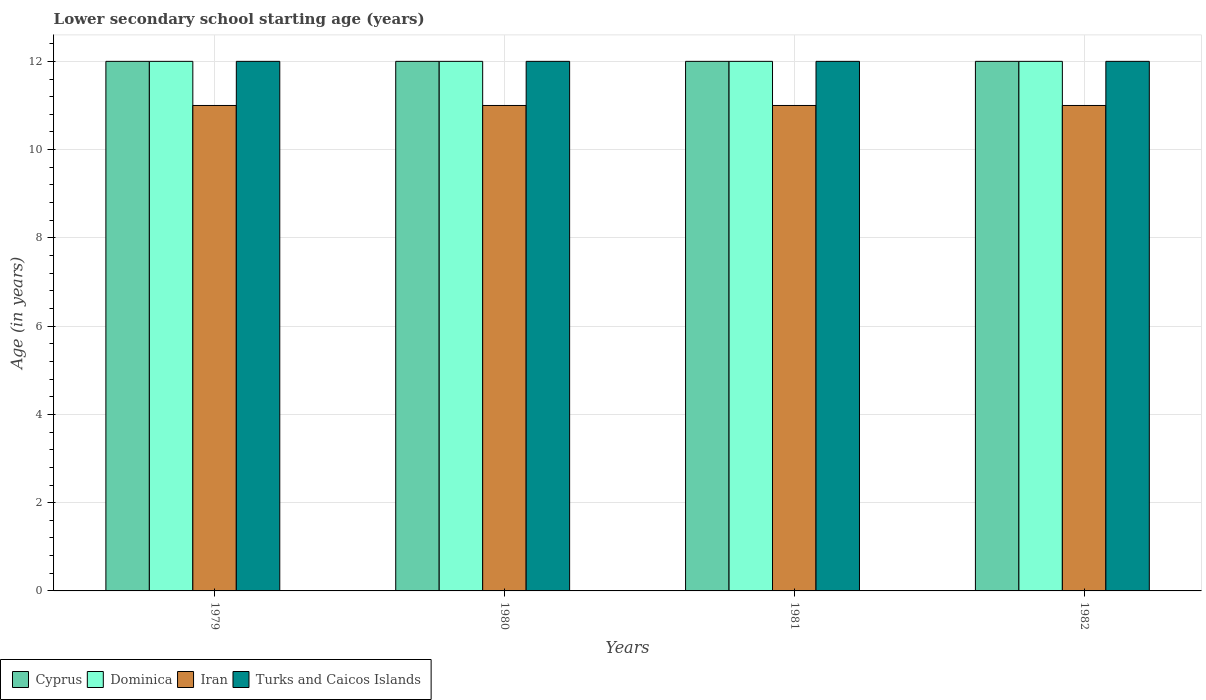How many bars are there on the 4th tick from the left?
Your answer should be very brief. 4. What is the label of the 1st group of bars from the left?
Provide a succinct answer. 1979. What is the lower secondary school starting age of children in Cyprus in 1982?
Offer a terse response. 12. Across all years, what is the minimum lower secondary school starting age of children in Iran?
Make the answer very short. 11. In which year was the lower secondary school starting age of children in Cyprus maximum?
Give a very brief answer. 1979. In which year was the lower secondary school starting age of children in Turks and Caicos Islands minimum?
Your response must be concise. 1979. What is the total lower secondary school starting age of children in Iran in the graph?
Your answer should be very brief. 44. What is the difference between the lower secondary school starting age of children in Cyprus in 1980 and that in 1981?
Provide a succinct answer. 0. In the year 1982, what is the difference between the lower secondary school starting age of children in Dominica and lower secondary school starting age of children in Cyprus?
Your answer should be compact. 0. What is the ratio of the lower secondary school starting age of children in Dominica in 1979 to that in 1982?
Provide a short and direct response. 1. What is the difference between the highest and the second highest lower secondary school starting age of children in Dominica?
Your answer should be very brief. 0. In how many years, is the lower secondary school starting age of children in Cyprus greater than the average lower secondary school starting age of children in Cyprus taken over all years?
Offer a very short reply. 0. Is it the case that in every year, the sum of the lower secondary school starting age of children in Dominica and lower secondary school starting age of children in Cyprus is greater than the sum of lower secondary school starting age of children in Turks and Caicos Islands and lower secondary school starting age of children in Iran?
Ensure brevity in your answer.  No. What does the 1st bar from the left in 1981 represents?
Your response must be concise. Cyprus. What does the 3rd bar from the right in 1981 represents?
Give a very brief answer. Dominica. Are all the bars in the graph horizontal?
Provide a succinct answer. No. What is the difference between two consecutive major ticks on the Y-axis?
Offer a terse response. 2. Are the values on the major ticks of Y-axis written in scientific E-notation?
Give a very brief answer. No. Where does the legend appear in the graph?
Your answer should be compact. Bottom left. How many legend labels are there?
Give a very brief answer. 4. How are the legend labels stacked?
Offer a terse response. Horizontal. What is the title of the graph?
Make the answer very short. Lower secondary school starting age (years). Does "Isle of Man" appear as one of the legend labels in the graph?
Provide a short and direct response. No. What is the label or title of the X-axis?
Ensure brevity in your answer.  Years. What is the label or title of the Y-axis?
Your answer should be very brief. Age (in years). What is the Age (in years) of Cyprus in 1979?
Provide a short and direct response. 12. What is the Age (in years) in Dominica in 1979?
Keep it short and to the point. 12. What is the Age (in years) of Turks and Caicos Islands in 1979?
Your response must be concise. 12. What is the Age (in years) in Turks and Caicos Islands in 1980?
Offer a terse response. 12. What is the Age (in years) in Cyprus in 1981?
Make the answer very short. 12. What is the Age (in years) of Iran in 1981?
Offer a terse response. 11. Across all years, what is the maximum Age (in years) of Iran?
Offer a very short reply. 11. Across all years, what is the minimum Age (in years) of Cyprus?
Your answer should be very brief. 12. Across all years, what is the minimum Age (in years) of Iran?
Your answer should be compact. 11. Across all years, what is the minimum Age (in years) of Turks and Caicos Islands?
Your response must be concise. 12. What is the total Age (in years) in Cyprus in the graph?
Offer a terse response. 48. What is the total Age (in years) in Dominica in the graph?
Your answer should be very brief. 48. What is the total Age (in years) of Iran in the graph?
Offer a terse response. 44. What is the total Age (in years) in Turks and Caicos Islands in the graph?
Give a very brief answer. 48. What is the difference between the Age (in years) in Turks and Caicos Islands in 1979 and that in 1980?
Your answer should be compact. 0. What is the difference between the Age (in years) in Cyprus in 1979 and that in 1981?
Your answer should be compact. 0. What is the difference between the Age (in years) in Dominica in 1979 and that in 1981?
Offer a very short reply. 0. What is the difference between the Age (in years) in Iran in 1979 and that in 1981?
Provide a short and direct response. 0. What is the difference between the Age (in years) of Turks and Caicos Islands in 1979 and that in 1981?
Your answer should be compact. 0. What is the difference between the Age (in years) of Iran in 1979 and that in 1982?
Provide a succinct answer. 0. What is the difference between the Age (in years) of Cyprus in 1980 and that in 1981?
Offer a very short reply. 0. What is the difference between the Age (in years) of Dominica in 1980 and that in 1982?
Your response must be concise. 0. What is the difference between the Age (in years) of Iran in 1981 and that in 1982?
Provide a succinct answer. 0. What is the difference between the Age (in years) in Turks and Caicos Islands in 1981 and that in 1982?
Keep it short and to the point. 0. What is the difference between the Age (in years) in Cyprus in 1979 and the Age (in years) in Dominica in 1980?
Your answer should be compact. 0. What is the difference between the Age (in years) in Cyprus in 1979 and the Age (in years) in Iran in 1980?
Make the answer very short. 1. What is the difference between the Age (in years) of Dominica in 1979 and the Age (in years) of Iran in 1980?
Provide a succinct answer. 1. What is the difference between the Age (in years) of Dominica in 1979 and the Age (in years) of Turks and Caicos Islands in 1980?
Ensure brevity in your answer.  0. What is the difference between the Age (in years) of Iran in 1979 and the Age (in years) of Turks and Caicos Islands in 1980?
Your answer should be compact. -1. What is the difference between the Age (in years) in Cyprus in 1979 and the Age (in years) in Iran in 1981?
Provide a short and direct response. 1. What is the difference between the Age (in years) of Cyprus in 1979 and the Age (in years) of Turks and Caicos Islands in 1981?
Offer a very short reply. 0. What is the difference between the Age (in years) of Iran in 1979 and the Age (in years) of Turks and Caicos Islands in 1981?
Offer a very short reply. -1. What is the difference between the Age (in years) in Cyprus in 1979 and the Age (in years) in Dominica in 1982?
Ensure brevity in your answer.  0. What is the difference between the Age (in years) in Cyprus in 1979 and the Age (in years) in Iran in 1982?
Keep it short and to the point. 1. What is the difference between the Age (in years) of Dominica in 1979 and the Age (in years) of Iran in 1982?
Keep it short and to the point. 1. What is the difference between the Age (in years) in Cyprus in 1980 and the Age (in years) in Dominica in 1981?
Your answer should be compact. 0. What is the difference between the Age (in years) in Cyprus in 1980 and the Age (in years) in Turks and Caicos Islands in 1981?
Your answer should be very brief. 0. What is the difference between the Age (in years) of Dominica in 1980 and the Age (in years) of Turks and Caicos Islands in 1981?
Make the answer very short. 0. What is the difference between the Age (in years) in Iran in 1980 and the Age (in years) in Turks and Caicos Islands in 1981?
Offer a terse response. -1. What is the difference between the Age (in years) of Cyprus in 1980 and the Age (in years) of Iran in 1982?
Your answer should be compact. 1. What is the difference between the Age (in years) of Cyprus in 1980 and the Age (in years) of Turks and Caicos Islands in 1982?
Give a very brief answer. 0. What is the difference between the Age (in years) in Cyprus in 1981 and the Age (in years) in Dominica in 1982?
Your answer should be very brief. 0. What is the difference between the Age (in years) in Cyprus in 1981 and the Age (in years) in Iran in 1982?
Ensure brevity in your answer.  1. What is the difference between the Age (in years) of Dominica in 1981 and the Age (in years) of Iran in 1982?
Give a very brief answer. 1. What is the difference between the Age (in years) in Dominica in 1981 and the Age (in years) in Turks and Caicos Islands in 1982?
Provide a succinct answer. 0. What is the average Age (in years) in Dominica per year?
Offer a very short reply. 12. In the year 1979, what is the difference between the Age (in years) in Cyprus and Age (in years) in Dominica?
Offer a terse response. 0. In the year 1979, what is the difference between the Age (in years) of Iran and Age (in years) of Turks and Caicos Islands?
Give a very brief answer. -1. In the year 1980, what is the difference between the Age (in years) in Cyprus and Age (in years) in Dominica?
Your response must be concise. 0. In the year 1980, what is the difference between the Age (in years) of Cyprus and Age (in years) of Iran?
Provide a succinct answer. 1. In the year 1980, what is the difference between the Age (in years) of Cyprus and Age (in years) of Turks and Caicos Islands?
Give a very brief answer. 0. In the year 1980, what is the difference between the Age (in years) of Dominica and Age (in years) of Iran?
Offer a terse response. 1. In the year 1980, what is the difference between the Age (in years) in Dominica and Age (in years) in Turks and Caicos Islands?
Provide a short and direct response. 0. In the year 1980, what is the difference between the Age (in years) of Iran and Age (in years) of Turks and Caicos Islands?
Provide a succinct answer. -1. In the year 1981, what is the difference between the Age (in years) of Cyprus and Age (in years) of Dominica?
Offer a terse response. 0. In the year 1981, what is the difference between the Age (in years) of Cyprus and Age (in years) of Turks and Caicos Islands?
Provide a succinct answer. 0. In the year 1981, what is the difference between the Age (in years) of Dominica and Age (in years) of Iran?
Ensure brevity in your answer.  1. In the year 1981, what is the difference between the Age (in years) in Dominica and Age (in years) in Turks and Caicos Islands?
Keep it short and to the point. 0. In the year 1982, what is the difference between the Age (in years) of Cyprus and Age (in years) of Dominica?
Provide a succinct answer. 0. In the year 1982, what is the difference between the Age (in years) in Cyprus and Age (in years) in Iran?
Your answer should be very brief. 1. In the year 1982, what is the difference between the Age (in years) in Dominica and Age (in years) in Iran?
Your answer should be compact. 1. In the year 1982, what is the difference between the Age (in years) in Iran and Age (in years) in Turks and Caicos Islands?
Make the answer very short. -1. What is the ratio of the Age (in years) of Cyprus in 1979 to that in 1980?
Give a very brief answer. 1. What is the ratio of the Age (in years) of Cyprus in 1979 to that in 1981?
Offer a very short reply. 1. What is the ratio of the Age (in years) in Iran in 1979 to that in 1981?
Give a very brief answer. 1. What is the ratio of the Age (in years) of Dominica in 1979 to that in 1982?
Your response must be concise. 1. What is the ratio of the Age (in years) of Turks and Caicos Islands in 1979 to that in 1982?
Your answer should be compact. 1. What is the ratio of the Age (in years) of Iran in 1980 to that in 1981?
Keep it short and to the point. 1. What is the ratio of the Age (in years) in Turks and Caicos Islands in 1980 to that in 1981?
Provide a succinct answer. 1. What is the ratio of the Age (in years) of Turks and Caicos Islands in 1980 to that in 1982?
Keep it short and to the point. 1. What is the ratio of the Age (in years) in Cyprus in 1981 to that in 1982?
Your answer should be compact. 1. What is the ratio of the Age (in years) of Turks and Caicos Islands in 1981 to that in 1982?
Your answer should be very brief. 1. What is the difference between the highest and the second highest Age (in years) of Cyprus?
Provide a succinct answer. 0. What is the difference between the highest and the second highest Age (in years) in Dominica?
Your answer should be compact. 0. What is the difference between the highest and the lowest Age (in years) in Cyprus?
Your response must be concise. 0. What is the difference between the highest and the lowest Age (in years) in Turks and Caicos Islands?
Ensure brevity in your answer.  0. 